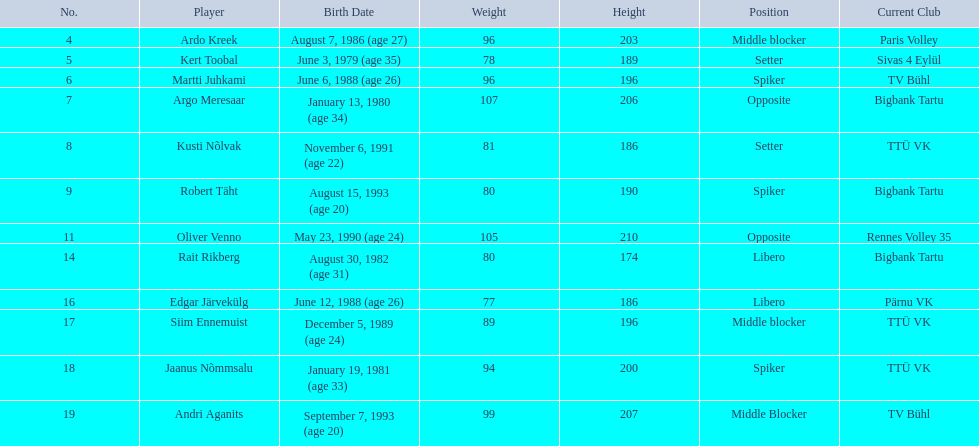Who are the athletes in the estonian men's national volleyball team? Ardo Kreek, Kert Toobal, Martti Juhkami, Argo Meresaar, Kusti Nõlvak, Robert Täht, Oliver Venno, Rait Rikberg, Edgar Järvekülg, Siim Ennemuist, Jaanus Nõmmsalu, Andri Aganits. Out of them, who has a height greater than 200? Ardo Kreek, Argo Meresaar, Oliver Venno, Andri Aganits. Of the remaining, who is the tallest? Oliver Venno. 